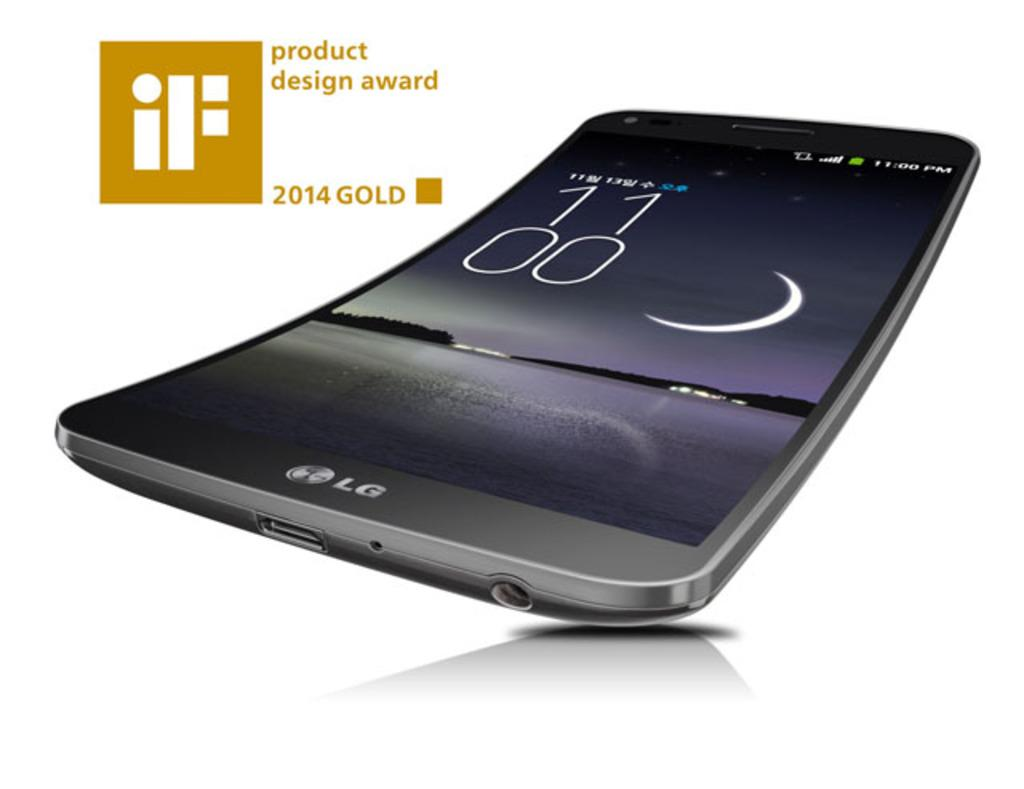<image>
Present a compact description of the photo's key features. The LG phone has won a product design award in 2014. 